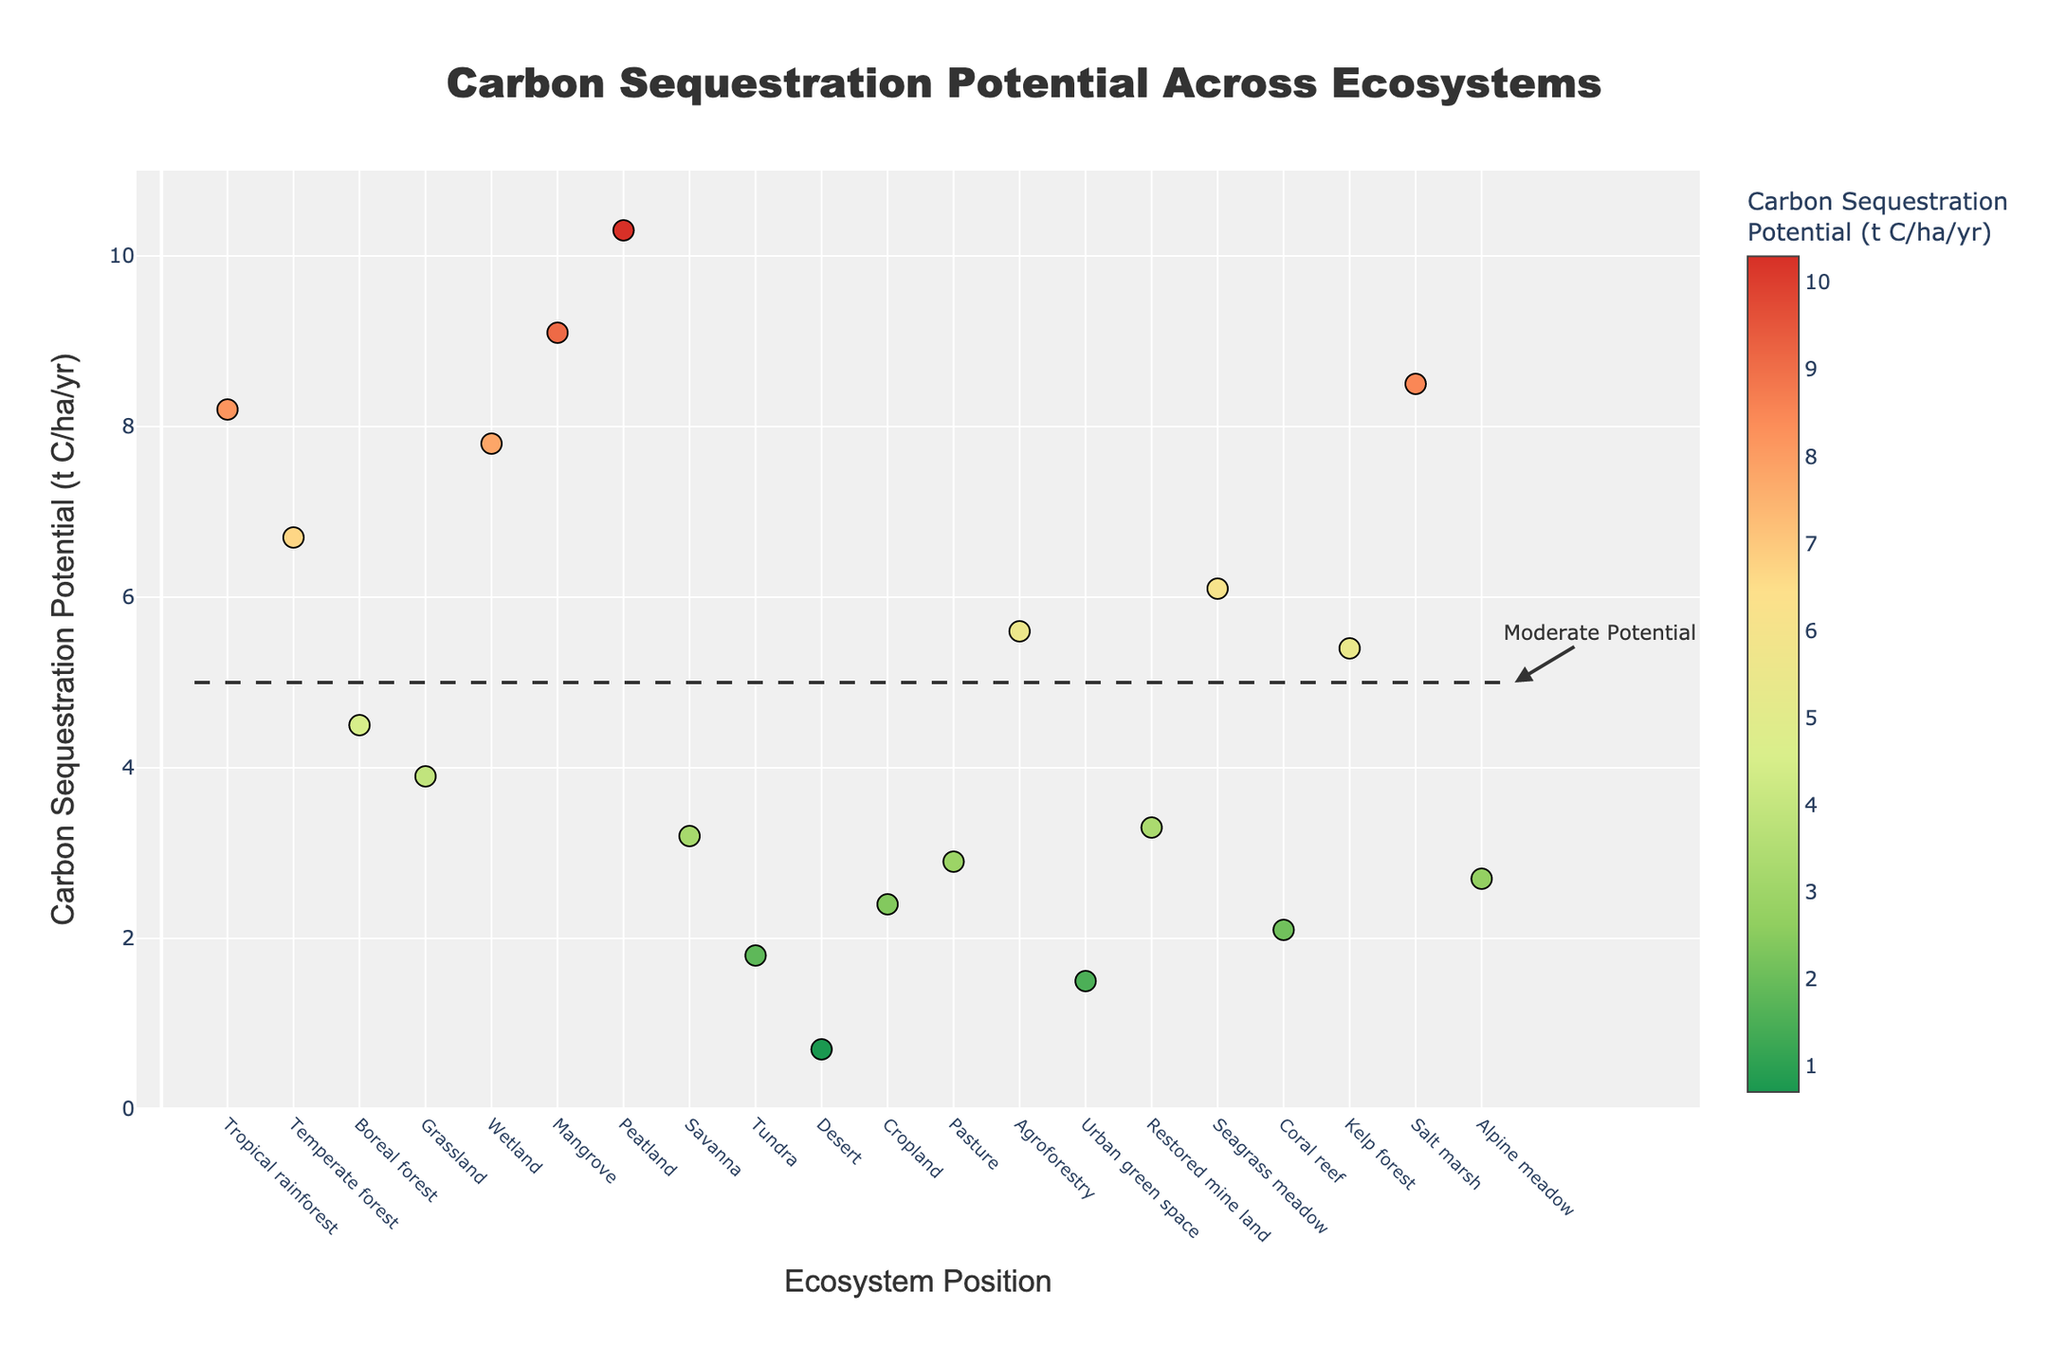what is the title of the plot? The title of the plot can be found at the top and is usually the largest text on the plot for easy identification. In this plot, the title reads 'Carbon Sequestration Potential Across Ecosystems'.
Answer: Carbon Sequestration Potential Across Ecosystems How many ecosystems are represented in the plot? Each marker on the x-axis corresponds to one ecosystem. By counting these markers, it's clear that there are 20 ecosystems represented.
Answer: 20 What is the carbon sequestration potential of the 'Mangrove' ecosystem? Hovering over the 'Mangrove' marker provides its data. According to the hover text, the carbon sequestration potential for 'Mangrove' is 9.1 t C/ha/yr.
Answer: 9.1 t C/ha/yr Which ecosystem has the lowest carbon sequestration potential? By looking at the y-axis values and identifying the lowest point on the scatter plot, we find the lowest carbon sequestration potential is at 'Desert', with a value of 0.7 t C/ha/yr.
Answer: Desert Which ecosystems have carbon sequestration potentials above the reference line (moderate potential) of 5 t C/ha/yr? Points above the horizontal reference line at the y-value of 5 t C/ha/yr are: Tropical rainforest, Temperate forest, Wetland, Mangrove, Peatland, Agroforestry, Seagrass meadow, Kelp forest, and Salt marsh.
Answer: Tropical rainforest, Temperate forest, Wetland, Mangrove, Peatland, Agroforestry, Seagrass meadow, Kelp forest, Salt marsh Calculate the average carbon sequestration potential for 'Grassland' and 'Savanna'. The values for 'Grassland' and 'Savanna' are 3.9 and 3.2 t C/ha/yr, respectively. The average is calculated as (3.9 + 3.2) / 2 = 3.55 t C/ha/yr.
Answer: 3.55 t C/ha/yr Compare the carbon sequestration potential of 'Tropical rainforest' and 'Temperate forest'. Which is higher, and by how much? The 'Tropical rainforest' has a carbon sequestration potential of 8.2 t C/ha/yr, while the 'Temperate forest' has 6.7 t C/ha/yr. The difference is 8.2 - 6.7 = 1.5 t C/ha/yr, making 'Tropical rainforest' higher by 1.5 t C/ha/yr.
Answer: Tropical rainforest, 1.5 t C/ha/yr How many ecosystems have a carbon sequestration potential lower than 5 t C/ha/yr? By counting the points below the horizontal reference line at 5 t C/ha/yr, there are 11 ecosystems: Boreal forest, Grassland, Savanna, Tundra, Desert, Cropland, Pasture, Urban green space, Coral reef, Restored mine land, and Alpine meadow.
Answer: 11 What's the median carbon sequestration potential value among all ecosystems? Ordering each carbon sequestration potential value and finding the middle value. Given that there are 20 values, the median is the average of the 10th and 11th values in the sorted list: (3.2 + 3.3) / 2 = 3.25 t C/ha/yr.
Answer: 3.25 t C/ha/yr Identify the ecosystem with the second highest carbon sequestration potential. The second highest value after Peatland (10.3 t C/ha/yr) is for Salt marsh with 8.5 t C/ha/yr.
Answer: Salt marsh 